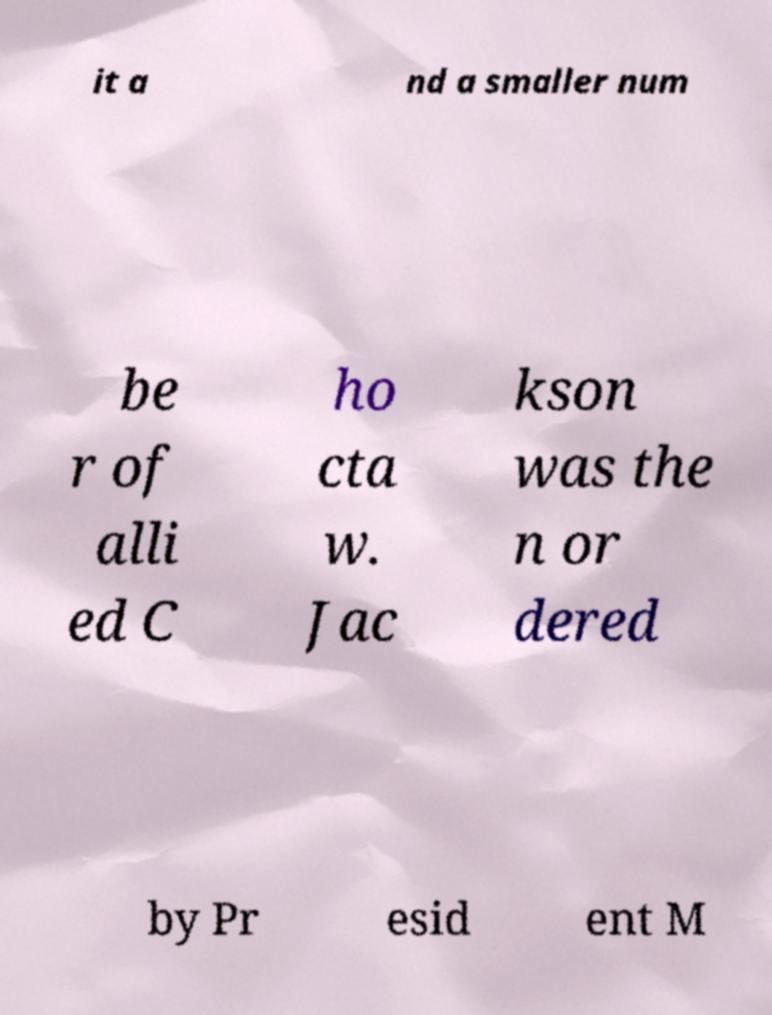There's text embedded in this image that I need extracted. Can you transcribe it verbatim? it a nd a smaller num be r of alli ed C ho cta w. Jac kson was the n or dered by Pr esid ent M 